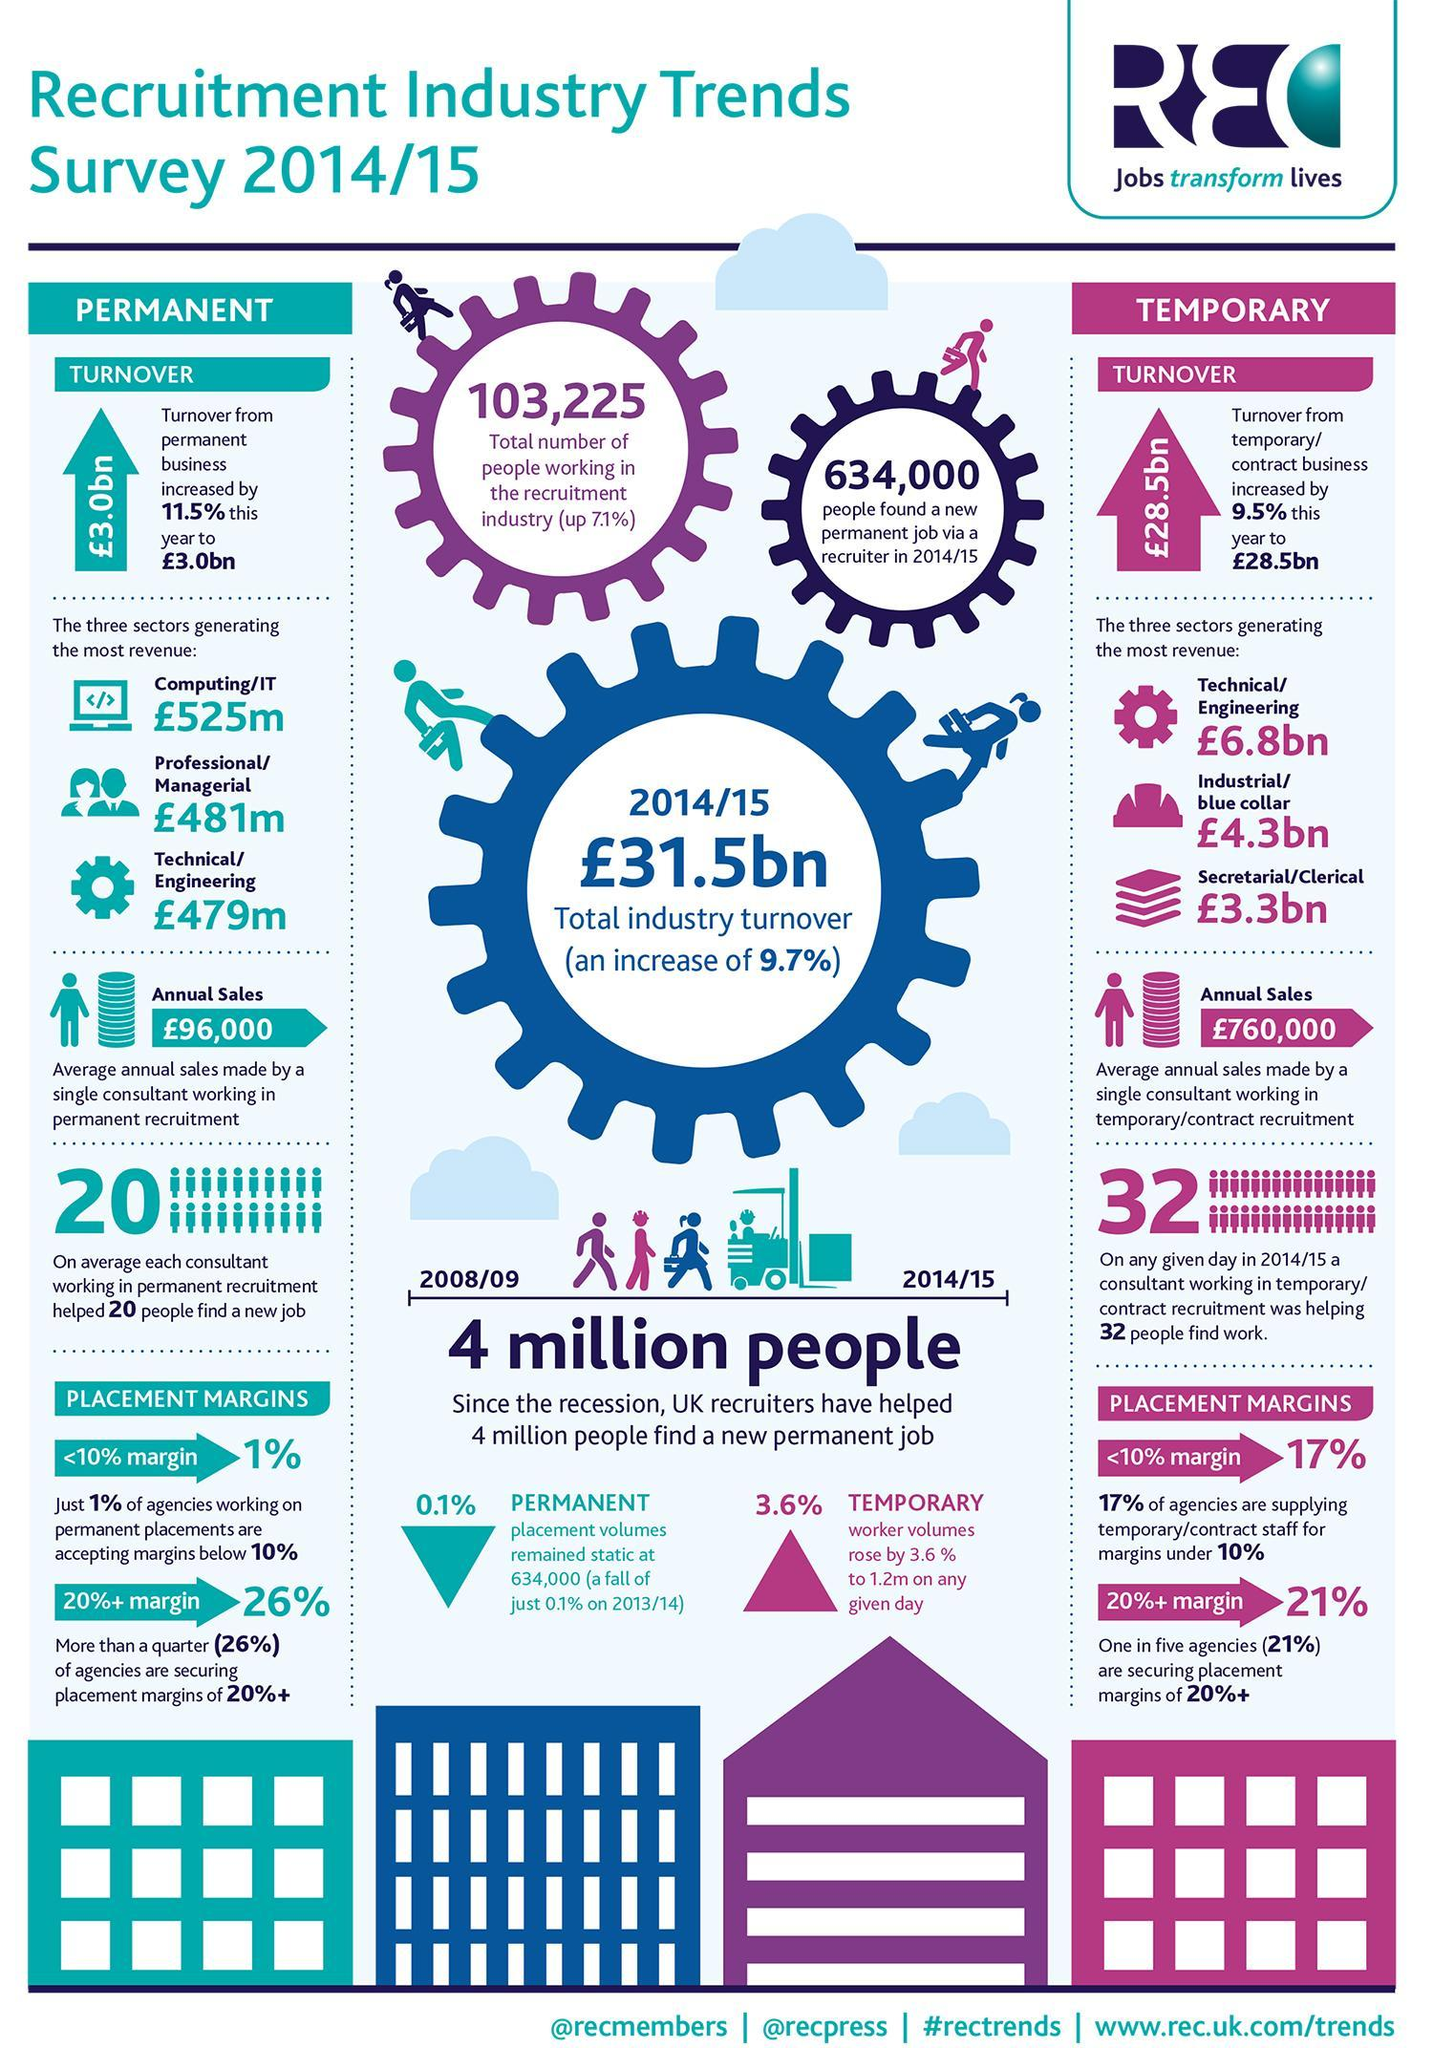What is the difference in revenue in billion between industrial/blue collar and secretarial/clerical
Answer the question with a short phrase. 1 which sector in temporary business is generating the second most revenue industrial/blue collar which sector in  permanent business is generating the second most revenue professional/managerial what percentage of agencies are securing placement margins of 20%+ in temporary business 21% what percentage of agencies are securing placement margins of 20%+ in permanent business 26% what is the % increase in turnover of permanent business 11.5 when was recession 2008/09 